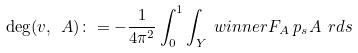<formula> <loc_0><loc_0><loc_500><loc_500>\deg ( v , \ A ) & \colon = - \frac { 1 } { 4 \pi ^ { 2 } } \int _ { 0 } ^ { 1 } \int _ { Y } \ w i n n e r { F _ { A } } { \ p _ { s } A } \, \ r d s</formula> 